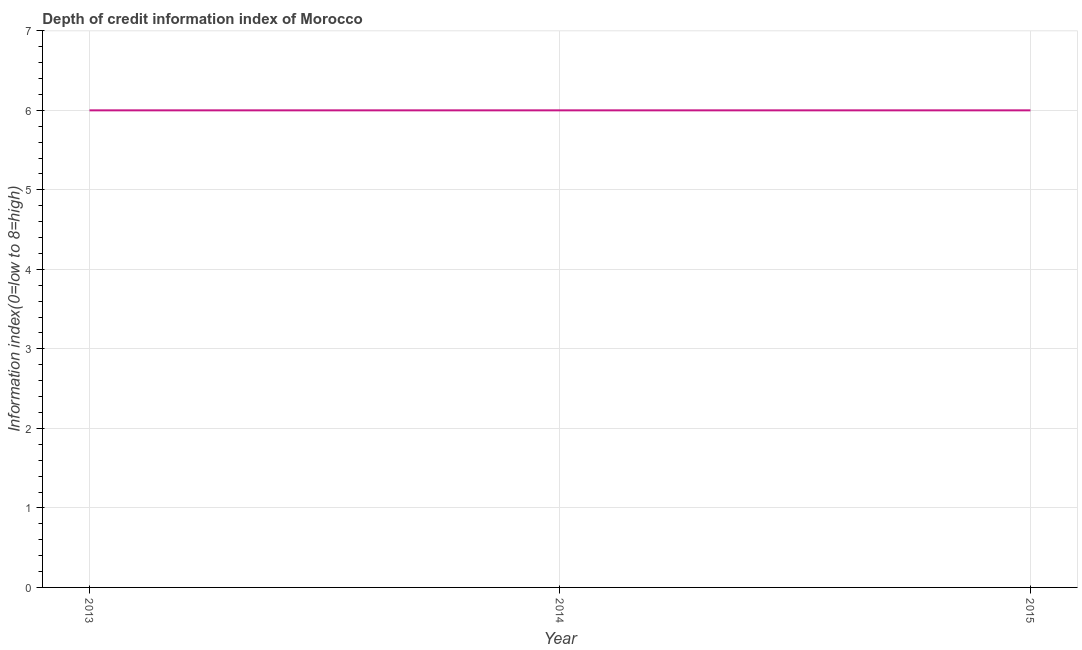What is the depth of credit information index in 2013?
Offer a terse response. 6. Across all years, what is the maximum depth of credit information index?
Offer a terse response. 6. In which year was the depth of credit information index maximum?
Your answer should be compact. 2013. What is the sum of the depth of credit information index?
Your answer should be very brief. 18. What is the average depth of credit information index per year?
Ensure brevity in your answer.  6. What is the median depth of credit information index?
Provide a short and direct response. 6. What is the ratio of the depth of credit information index in 2013 to that in 2014?
Your answer should be very brief. 1. Is the difference between the depth of credit information index in 2013 and 2014 greater than the difference between any two years?
Make the answer very short. Yes. What is the difference between the highest and the second highest depth of credit information index?
Your answer should be compact. 0. What is the difference between the highest and the lowest depth of credit information index?
Keep it short and to the point. 0. How many years are there in the graph?
Your answer should be compact. 3. What is the difference between two consecutive major ticks on the Y-axis?
Provide a succinct answer. 1. Does the graph contain grids?
Offer a terse response. Yes. What is the title of the graph?
Give a very brief answer. Depth of credit information index of Morocco. What is the label or title of the Y-axis?
Provide a short and direct response. Information index(0=low to 8=high). What is the Information index(0=low to 8=high) in 2013?
Make the answer very short. 6. What is the Information index(0=low to 8=high) of 2014?
Ensure brevity in your answer.  6. What is the Information index(0=low to 8=high) in 2015?
Provide a short and direct response. 6. What is the difference between the Information index(0=low to 8=high) in 2013 and 2014?
Your response must be concise. 0. What is the ratio of the Information index(0=low to 8=high) in 2013 to that in 2014?
Keep it short and to the point. 1. What is the ratio of the Information index(0=low to 8=high) in 2014 to that in 2015?
Ensure brevity in your answer.  1. 